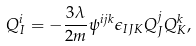Convert formula to latex. <formula><loc_0><loc_0><loc_500><loc_500>Q ^ { i } _ { I } = - \frac { 3 \lambda } { 2 m } \psi ^ { i j k } \epsilon _ { I J K } Q ^ { j } _ { J } Q ^ { k } _ { K } ,</formula> 